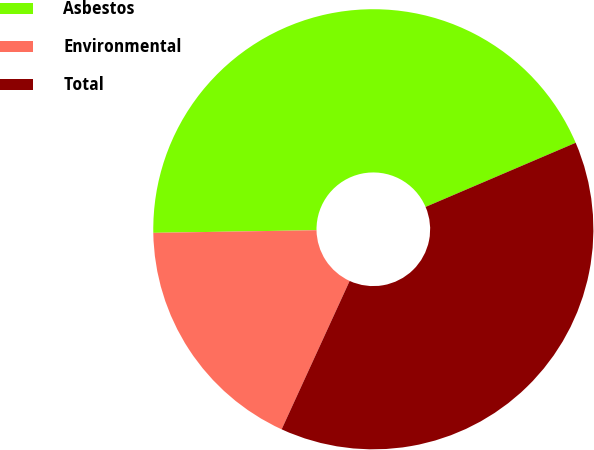Convert chart to OTSL. <chart><loc_0><loc_0><loc_500><loc_500><pie_chart><fcel>Asbestos<fcel>Environmental<fcel>Total<nl><fcel>43.83%<fcel>17.9%<fcel>38.27%<nl></chart> 